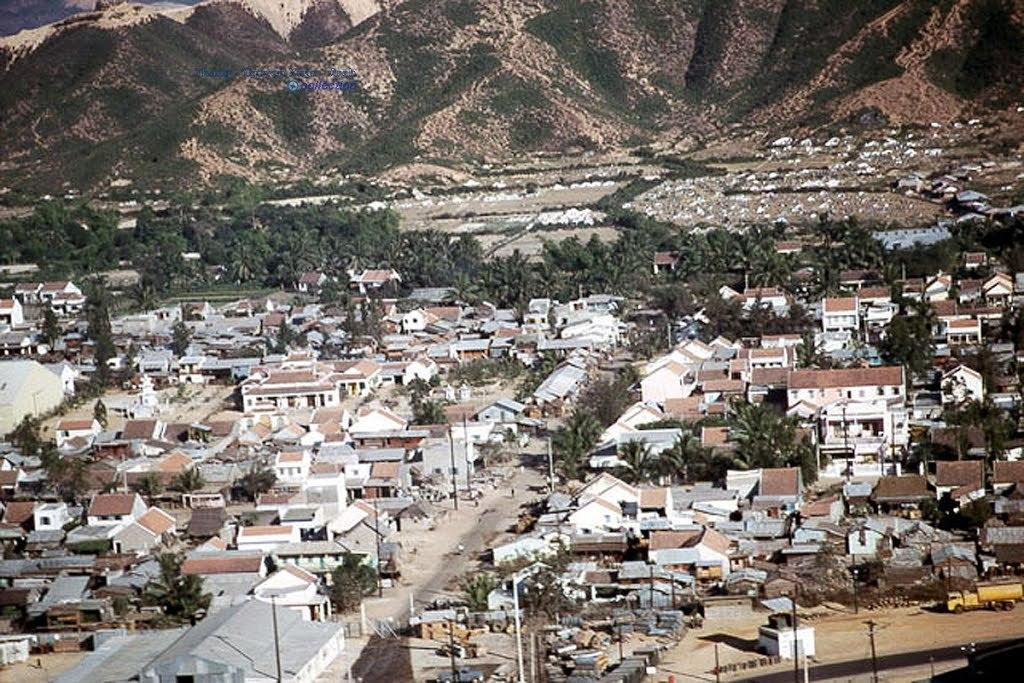What type of structures can be seen in the image? There are many buildings in the image. What natural elements are present in the image? There are many trees in the image. What can be seen in the distance in the image? There are hills visible in the background of the image. What type of infrastructure is present on the road in the image? There are street light poles on the road in the image. How many robins can be seen perched on the street light poles in the image? There are no robins present in the image; it features buildings, trees, hills, and street light poles. 